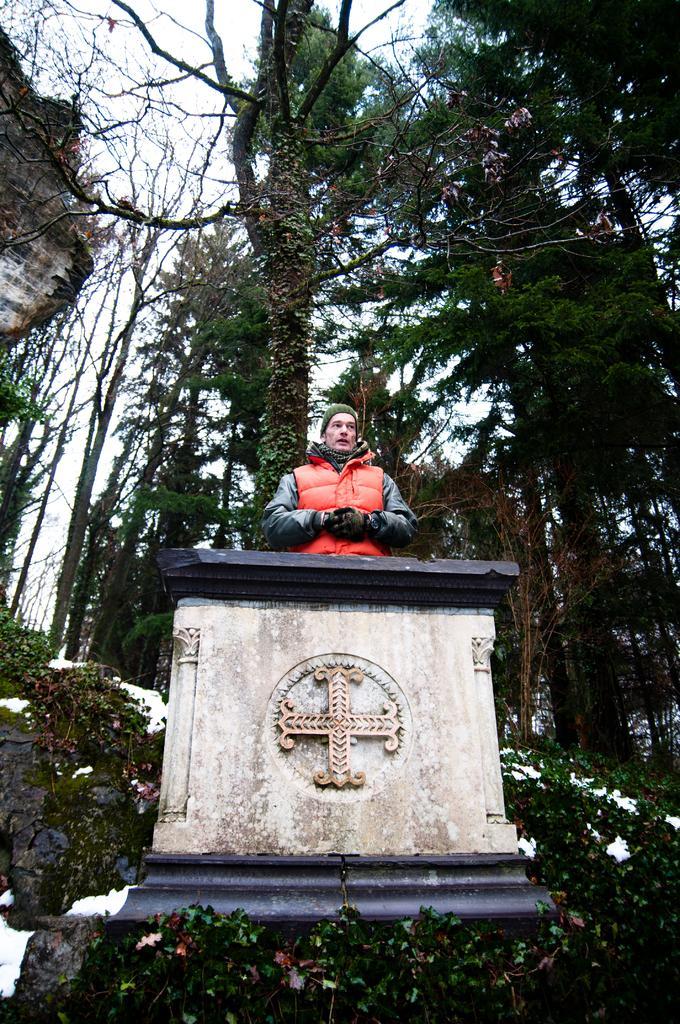Please provide a concise description of this image. There is a statue at the bottom of this image, and there are some trees in the background. There is a sky at the top of this image. 